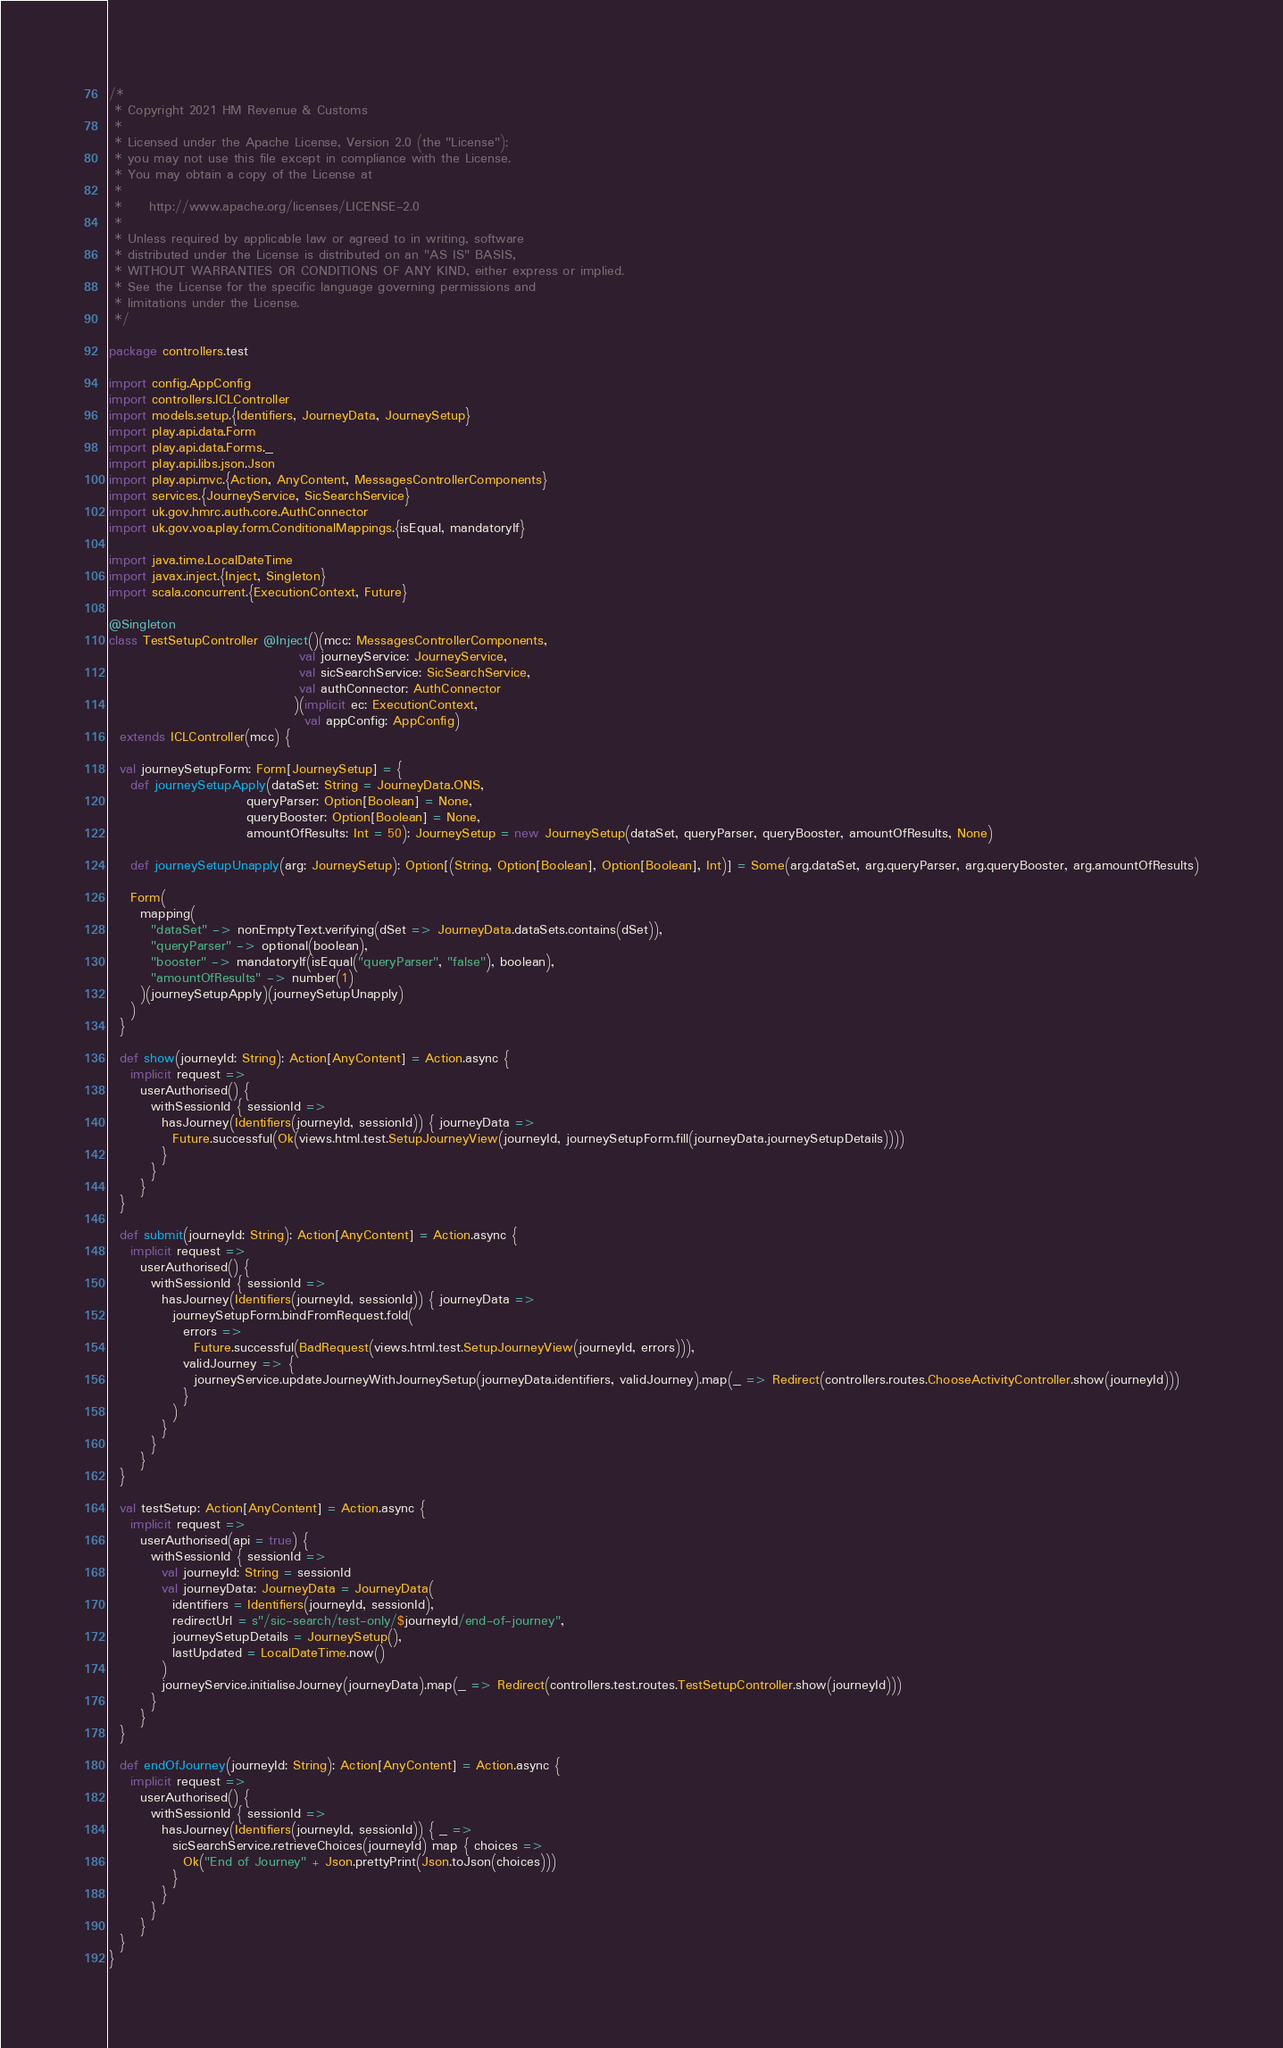<code> <loc_0><loc_0><loc_500><loc_500><_Scala_>/*
 * Copyright 2021 HM Revenue & Customs
 *
 * Licensed under the Apache License, Version 2.0 (the "License");
 * you may not use this file except in compliance with the License.
 * You may obtain a copy of the License at
 *
 *     http://www.apache.org/licenses/LICENSE-2.0
 *
 * Unless required by applicable law or agreed to in writing, software
 * distributed under the License is distributed on an "AS IS" BASIS,
 * WITHOUT WARRANTIES OR CONDITIONS OF ANY KIND, either express or implied.
 * See the License for the specific language governing permissions and
 * limitations under the License.
 */

package controllers.test

import config.AppConfig
import controllers.ICLController
import models.setup.{Identifiers, JourneyData, JourneySetup}
import play.api.data.Form
import play.api.data.Forms._
import play.api.libs.json.Json
import play.api.mvc.{Action, AnyContent, MessagesControllerComponents}
import services.{JourneyService, SicSearchService}
import uk.gov.hmrc.auth.core.AuthConnector
import uk.gov.voa.play.form.ConditionalMappings.{isEqual, mandatoryIf}

import java.time.LocalDateTime
import javax.inject.{Inject, Singleton}
import scala.concurrent.{ExecutionContext, Future}

@Singleton
class TestSetupController @Inject()(mcc: MessagesControllerComponents,
                                    val journeyService: JourneyService,
                                    val sicSearchService: SicSearchService,
                                    val authConnector: AuthConnector
                                   )(implicit ec: ExecutionContext,
                                     val appConfig: AppConfig)
  extends ICLController(mcc) {

  val journeySetupForm: Form[JourneySetup] = {
    def journeySetupApply(dataSet: String = JourneyData.ONS,
                          queryParser: Option[Boolean] = None,
                          queryBooster: Option[Boolean] = None,
                          amountOfResults: Int = 50): JourneySetup = new JourneySetup(dataSet, queryParser, queryBooster, amountOfResults, None)

    def journeySetupUnapply(arg: JourneySetup): Option[(String, Option[Boolean], Option[Boolean], Int)] = Some(arg.dataSet, arg.queryParser, arg.queryBooster, arg.amountOfResults)

    Form(
      mapping(
        "dataSet" -> nonEmptyText.verifying(dSet => JourneyData.dataSets.contains(dSet)),
        "queryParser" -> optional(boolean),
        "booster" -> mandatoryIf(isEqual("queryParser", "false"), boolean),
        "amountOfResults" -> number(1)
      )(journeySetupApply)(journeySetupUnapply)
    )
  }

  def show(journeyId: String): Action[AnyContent] = Action.async {
    implicit request =>
      userAuthorised() {
        withSessionId { sessionId =>
          hasJourney(Identifiers(journeyId, sessionId)) { journeyData =>
            Future.successful(Ok(views.html.test.SetupJourneyView(journeyId, journeySetupForm.fill(journeyData.journeySetupDetails))))
          }
        }
      }
  }

  def submit(journeyId: String): Action[AnyContent] = Action.async {
    implicit request =>
      userAuthorised() {
        withSessionId { sessionId =>
          hasJourney(Identifiers(journeyId, sessionId)) { journeyData =>
            journeySetupForm.bindFromRequest.fold(
              errors =>
                Future.successful(BadRequest(views.html.test.SetupJourneyView(journeyId, errors))),
              validJourney => {
                journeyService.updateJourneyWithJourneySetup(journeyData.identifiers, validJourney).map(_ => Redirect(controllers.routes.ChooseActivityController.show(journeyId)))
              }
            )
          }
        }
      }
  }

  val testSetup: Action[AnyContent] = Action.async {
    implicit request =>
      userAuthorised(api = true) {
        withSessionId { sessionId =>
          val journeyId: String = sessionId
          val journeyData: JourneyData = JourneyData(
            identifiers = Identifiers(journeyId, sessionId),
            redirectUrl = s"/sic-search/test-only/$journeyId/end-of-journey",
            journeySetupDetails = JourneySetup(),
            lastUpdated = LocalDateTime.now()
          )
          journeyService.initialiseJourney(journeyData).map(_ => Redirect(controllers.test.routes.TestSetupController.show(journeyId)))
        }
      }
  }

  def endOfJourney(journeyId: String): Action[AnyContent] = Action.async {
    implicit request =>
      userAuthorised() {
        withSessionId { sessionId =>
          hasJourney(Identifiers(journeyId, sessionId)) { _ =>
            sicSearchService.retrieveChoices(journeyId) map { choices =>
              Ok("End of Journey" + Json.prettyPrint(Json.toJson(choices)))
            }
          }
        }
      }
  }
}</code> 